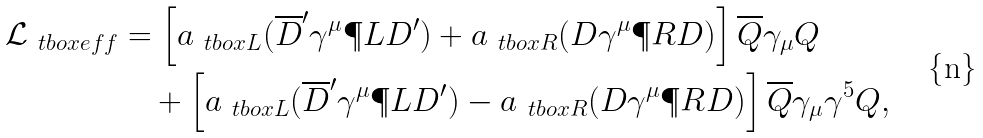<formula> <loc_0><loc_0><loc_500><loc_500>\mathcal { L } _ { \ t b o x { e f f } } & = \left [ a _ { \ t b o x { L } } ( \overline { D } ^ { \prime } \gamma ^ { \mu } \P L D ^ { \prime } ) + a _ { \ t b o x { R } } ( D \gamma ^ { \mu } \P R D ) \right ] \overline { Q } \gamma _ { \mu } Q \\ & \quad + \left [ a _ { \ t b o x { L } } ( \overline { D } ^ { \prime } \gamma ^ { \mu } \P L D ^ { \prime } ) - a _ { \ t b o x { R } } ( D \gamma ^ { \mu } \P R D ) \right ] \overline { Q } \gamma _ { \mu } \gamma ^ { 5 } Q ,</formula> 